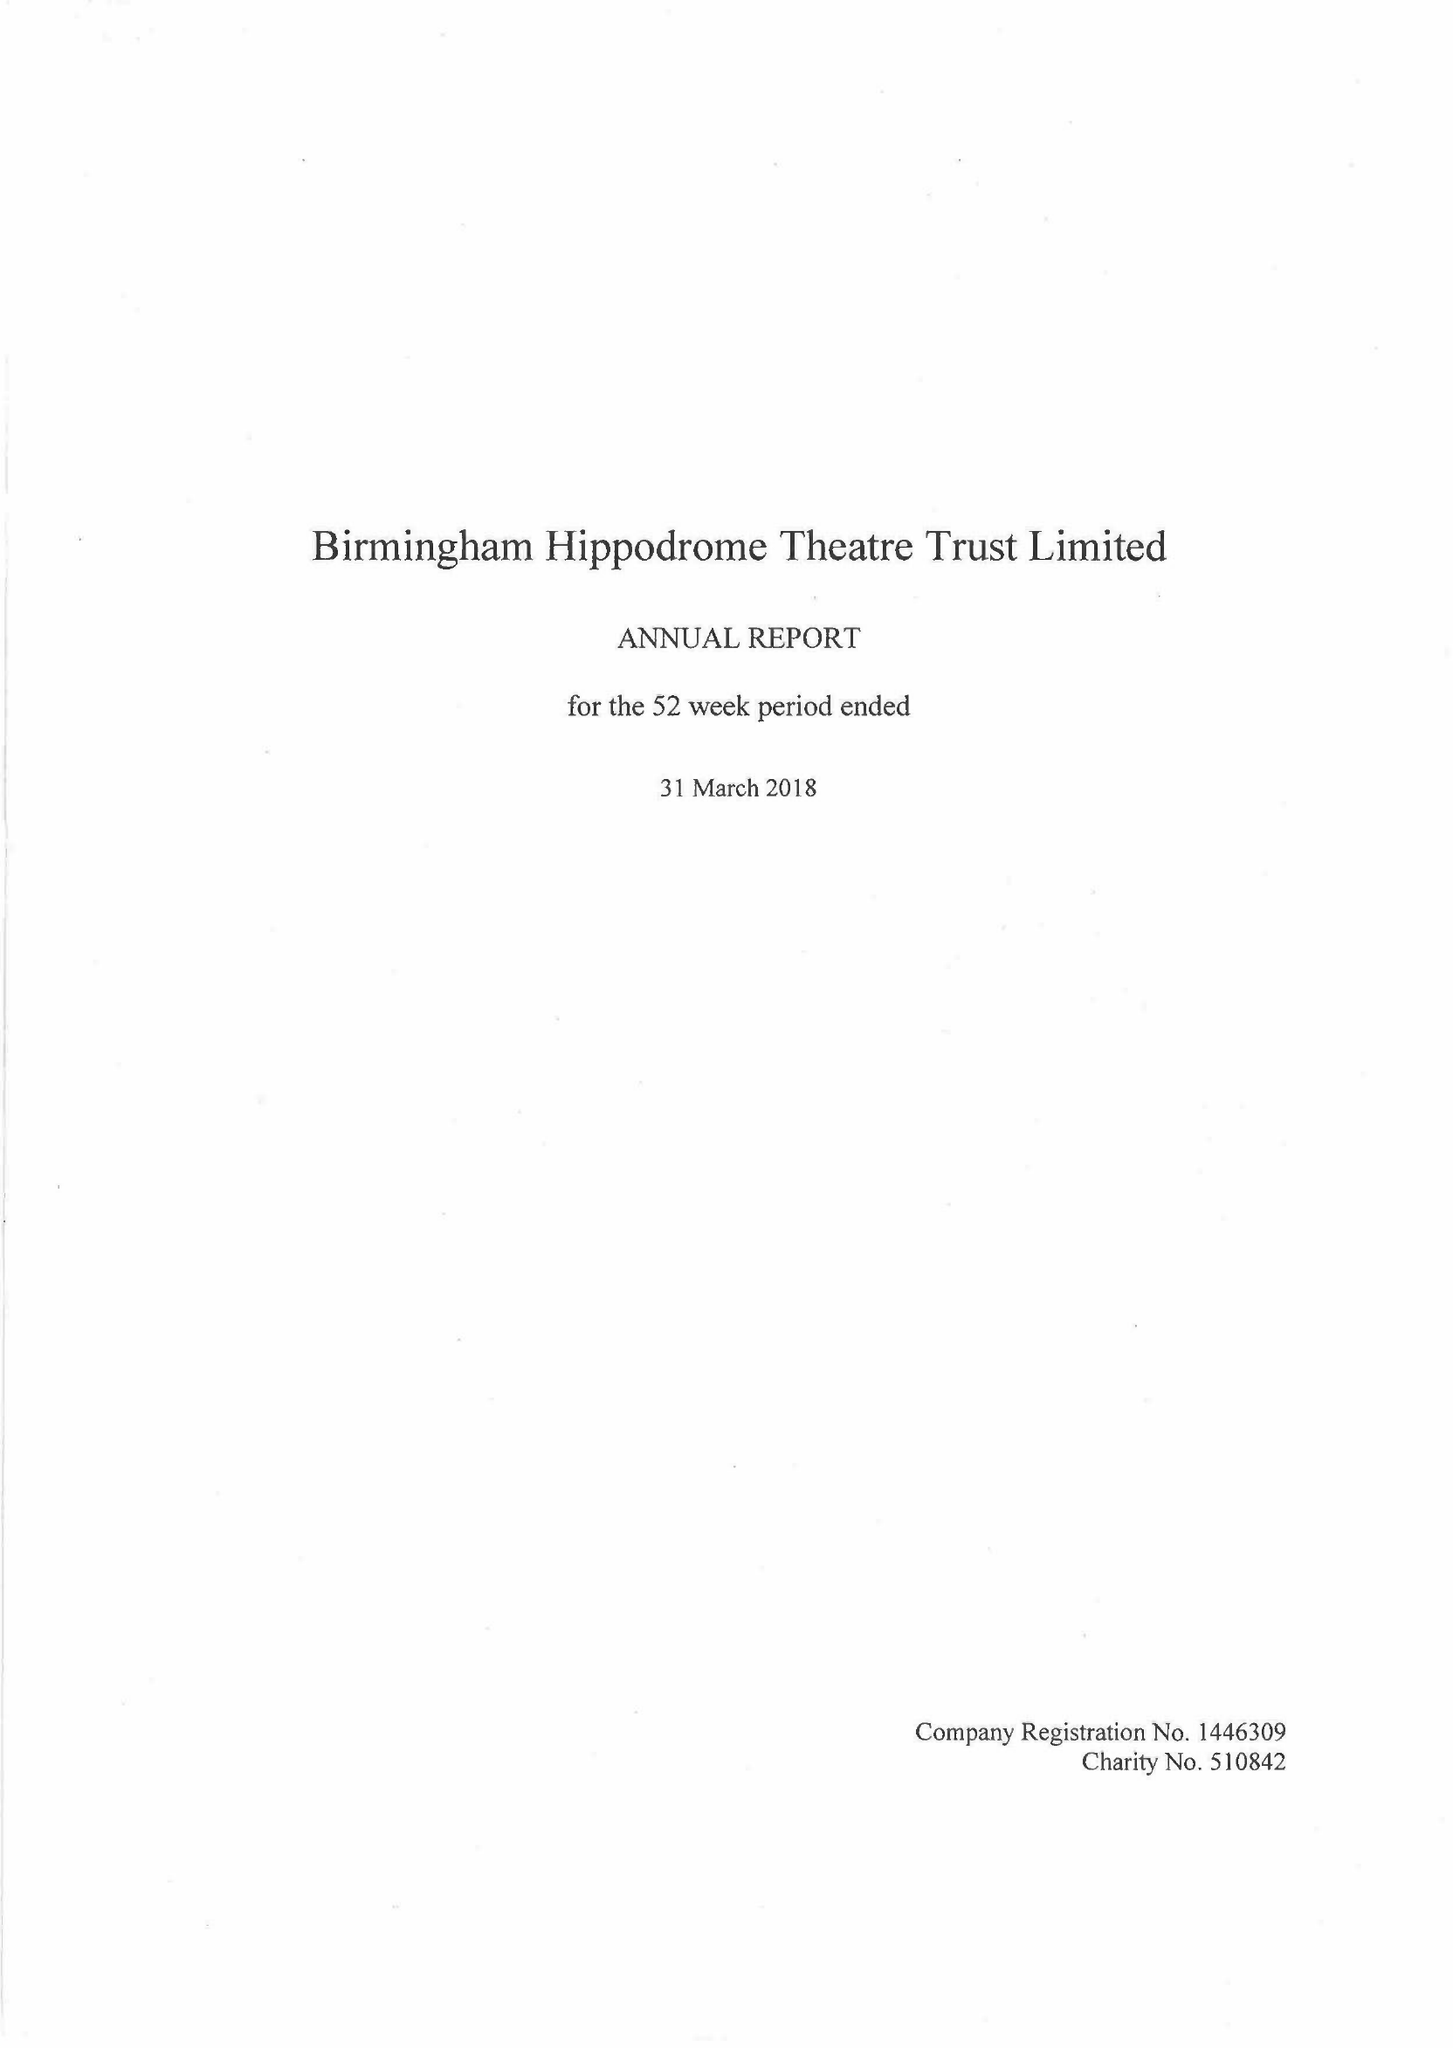What is the value for the report_date?
Answer the question using a single word or phrase. 2018-03-31 